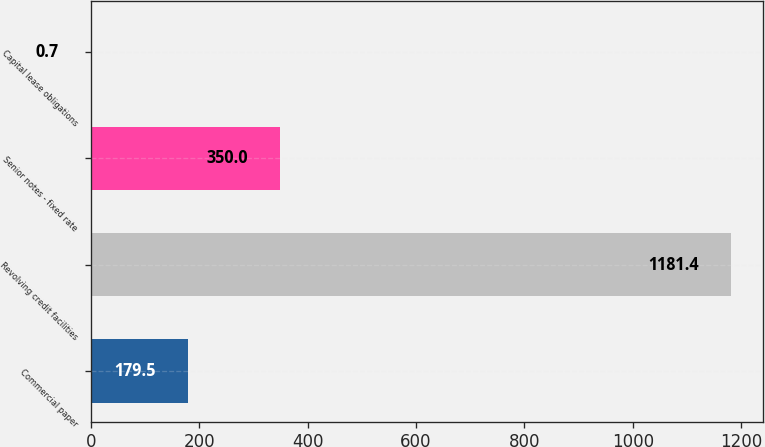Convert chart to OTSL. <chart><loc_0><loc_0><loc_500><loc_500><bar_chart><fcel>Commercial paper<fcel>Revolving credit facilities<fcel>Senior notes - fixed rate<fcel>Capital lease obligations<nl><fcel>179.5<fcel>1181.4<fcel>350<fcel>0.7<nl></chart> 